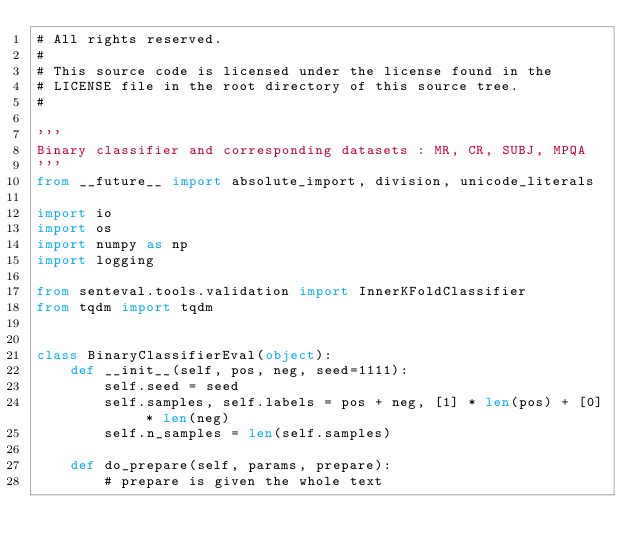<code> <loc_0><loc_0><loc_500><loc_500><_Python_># All rights reserved.
#
# This source code is licensed under the license found in the
# LICENSE file in the root directory of this source tree.
#

'''
Binary classifier and corresponding datasets : MR, CR, SUBJ, MPQA
'''
from __future__ import absolute_import, division, unicode_literals

import io
import os
import numpy as np
import logging

from senteval.tools.validation import InnerKFoldClassifier
from tqdm import tqdm


class BinaryClassifierEval(object):
    def __init__(self, pos, neg, seed=1111):
        self.seed = seed
        self.samples, self.labels = pos + neg, [1] * len(pos) + [0] * len(neg)
        self.n_samples = len(self.samples)

    def do_prepare(self, params, prepare):
        # prepare is given the whole text</code> 